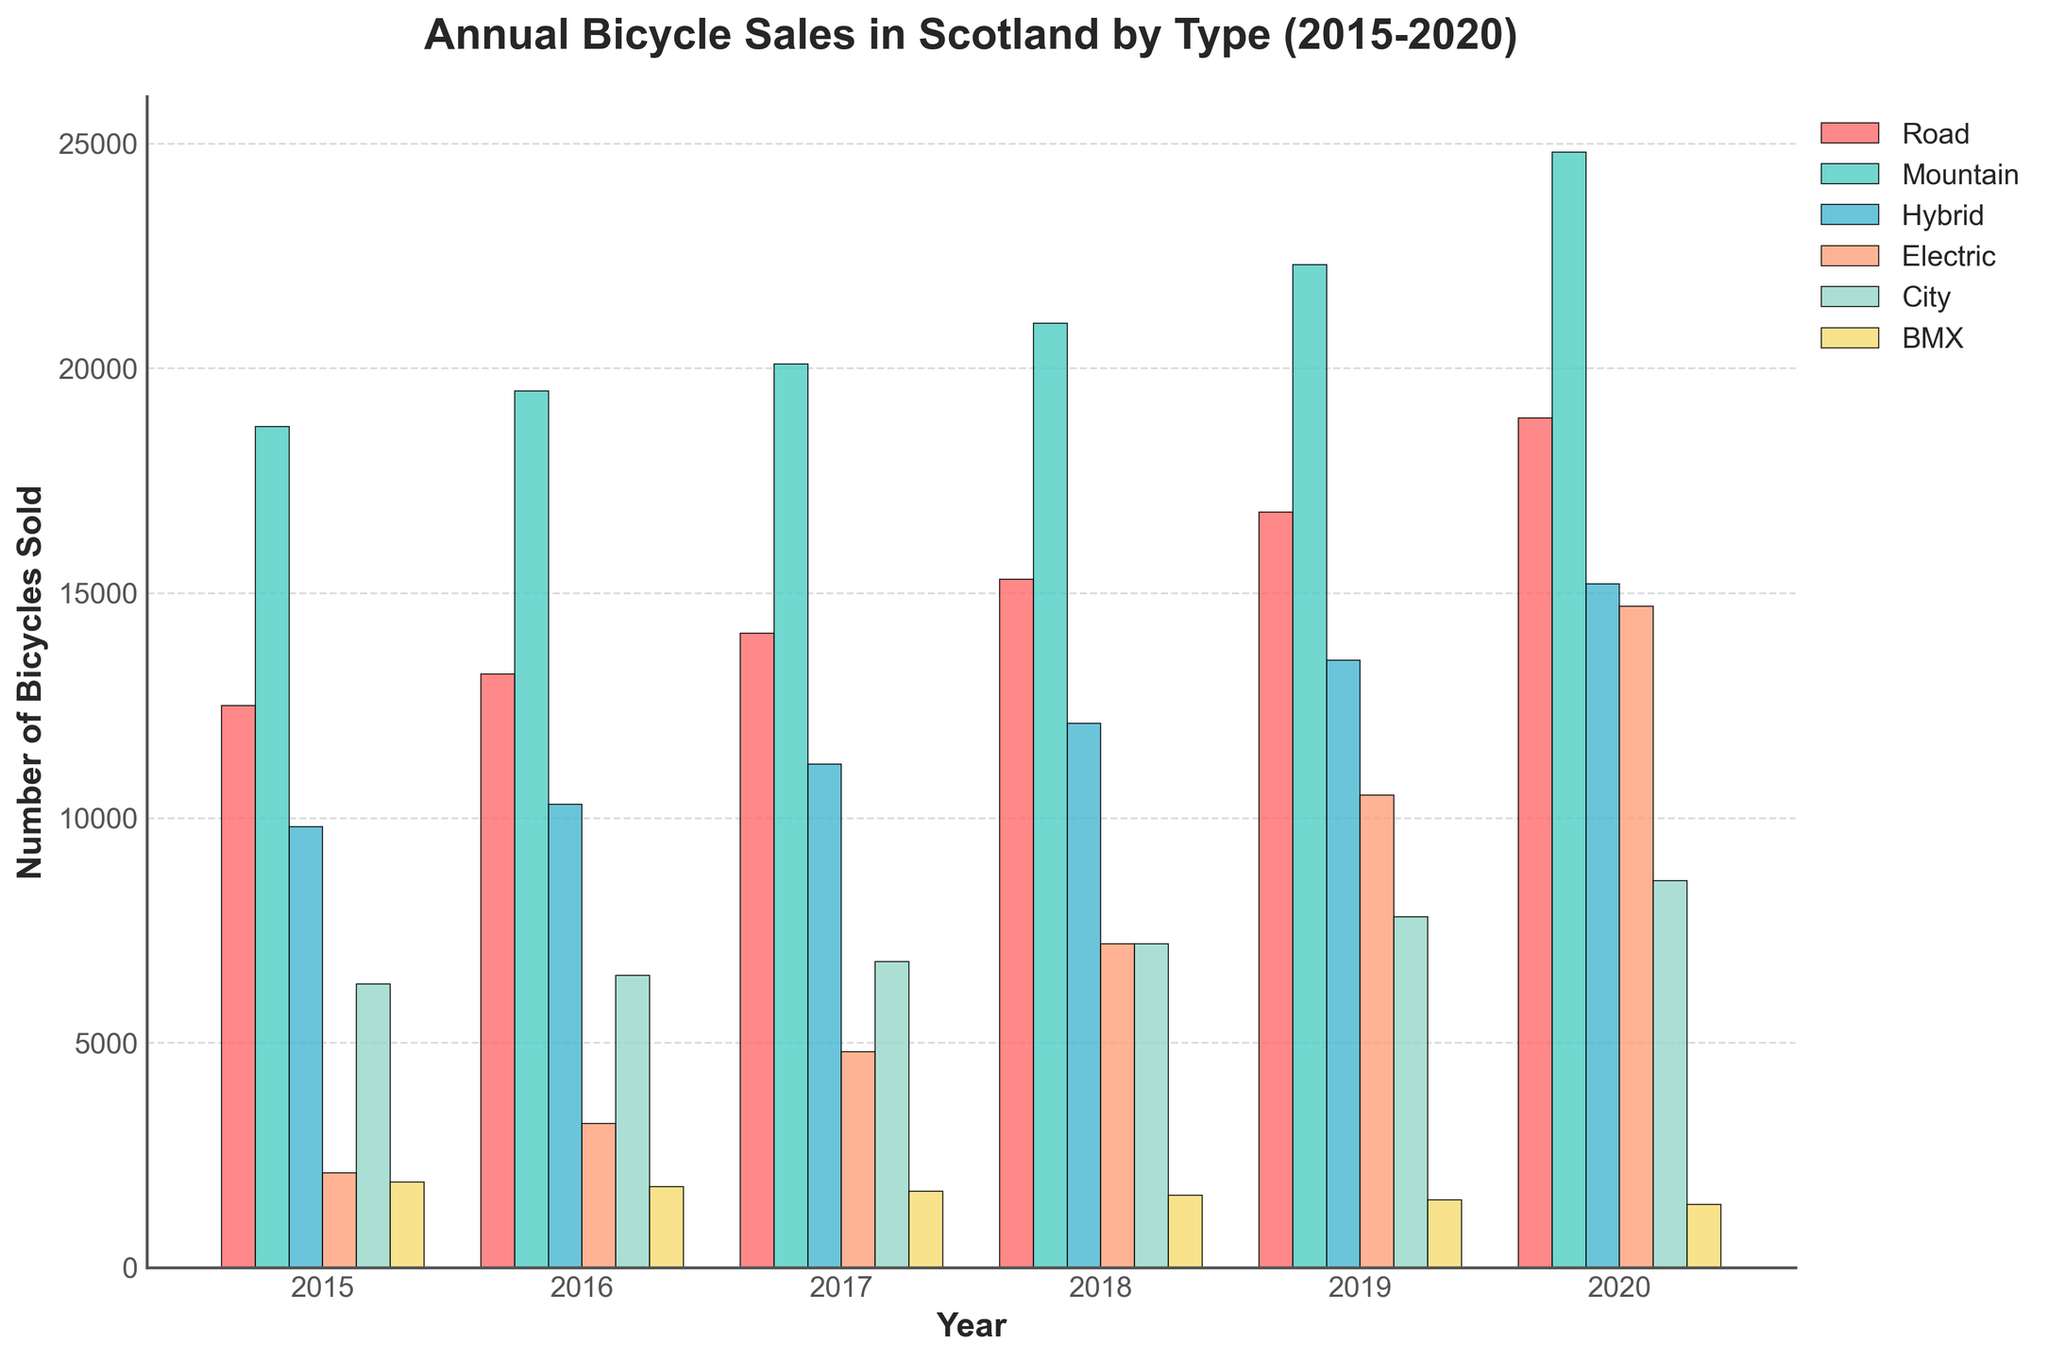What type of bicycle had the highest sales in 2020? The highest bar in 2020 is for Mountain bikes with a value of 24,800
Answer: Mountain bikes Which year saw the biggest increase in Electric bike sales compared to the previous year? The Electric bikes saw the biggest increase from 2019 to 2020, rising from 10,500 to 14,700, a difference of 4,200
Answer: 2019 to 2020 Between 2019 and 2020, did any type of bicycle experience a decrease in sales? Observing the bars from 2019 to 2020, all types of bicycles saw an increase, none experienced a decrease
Answer: No In what year did City bike sales surpass BMX bike sales for the first time? City bikes surpassed BMX bikes every year shown on the chart. In 2015, City bikes sold 6,300 while BMX bikes sold 1,900
Answer: 2015 By how much did Road bike sales grow from 2015 to 2020? The sales of Road bikes in 2015 were 12,500 and in 2020 were 18,900. The growth is 18,900 - 12,500 = 6,400
Answer: 6,400 Which type of bike had the smallest number of sales consistently across all years? The smallest bars for all years belong to BMX bikes. In 2015, sales were 1,900, and in 2020, they were 1,400
Answer: BMX Are there any years where the sales of Hybrid bikes were higher than Road bikes? The bars for Hybrid bikes are always lower than those for Road bikes each year on the chart
Answer: No How did Mountain bike sales in 2017 compare to City bike sales in the same year? Mountain bike sales were 20,100 while City bike sales were 6,800. Mountain bikes sold 20,100 - 6,800 = 13,300 more
Answer: 13,300 more Which type of bike had the most significant sales increase between 2015 and 2020? Comparing 2015 to 2020, Electric bikes had the largest increase from 2,100 to 14,700, an increase of 12,600
Answer: Electric What was the total number of all types of bicycle sales in 2018? Summing the sales of all types in 2018: 15,300 + 21,000 + 12,100 + 7,200 + 7,200 + 1,600 = 64,400
Answer: 64,400 